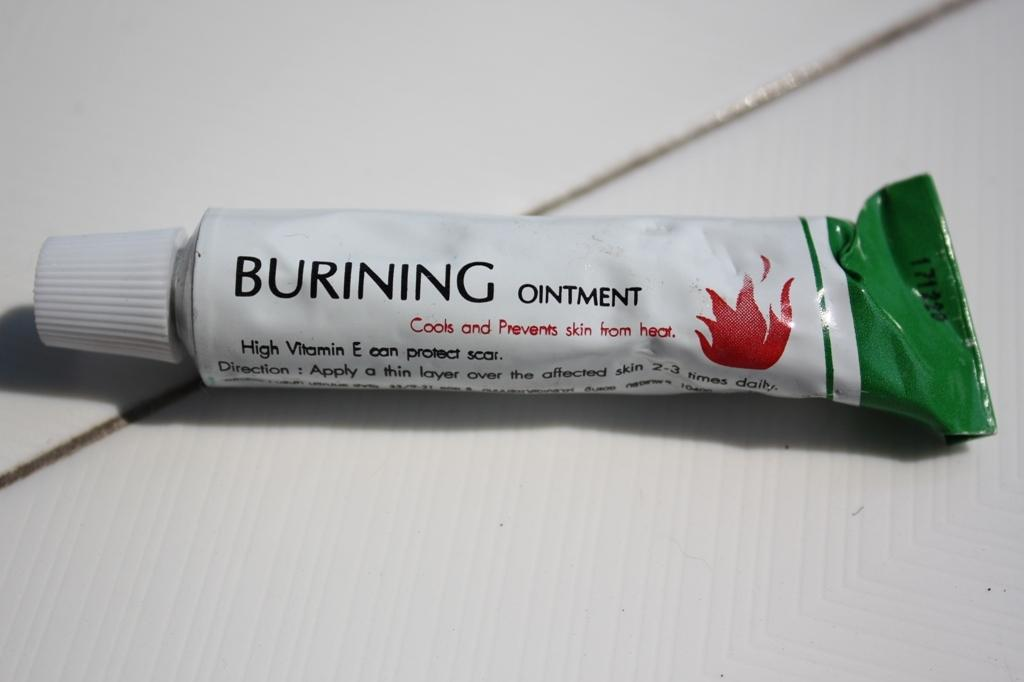<image>
Offer a succinct explanation of the picture presented. A tube of Burning ointment with vitamin e to stop heat from harming skin 